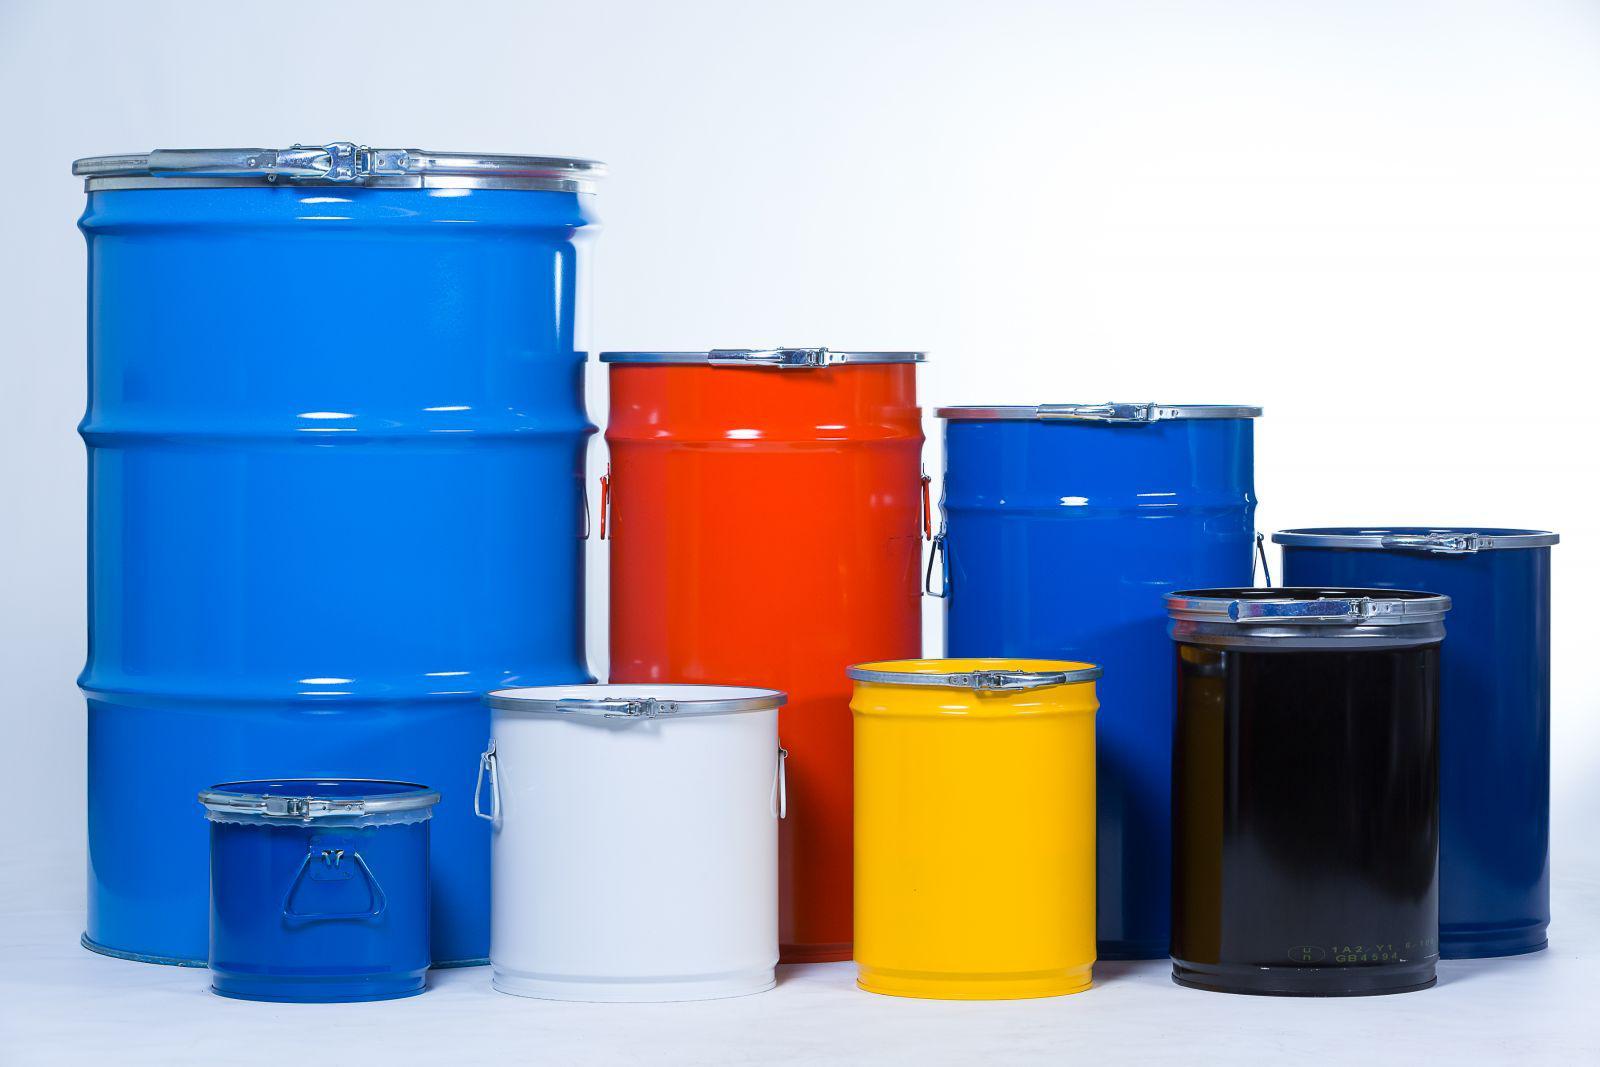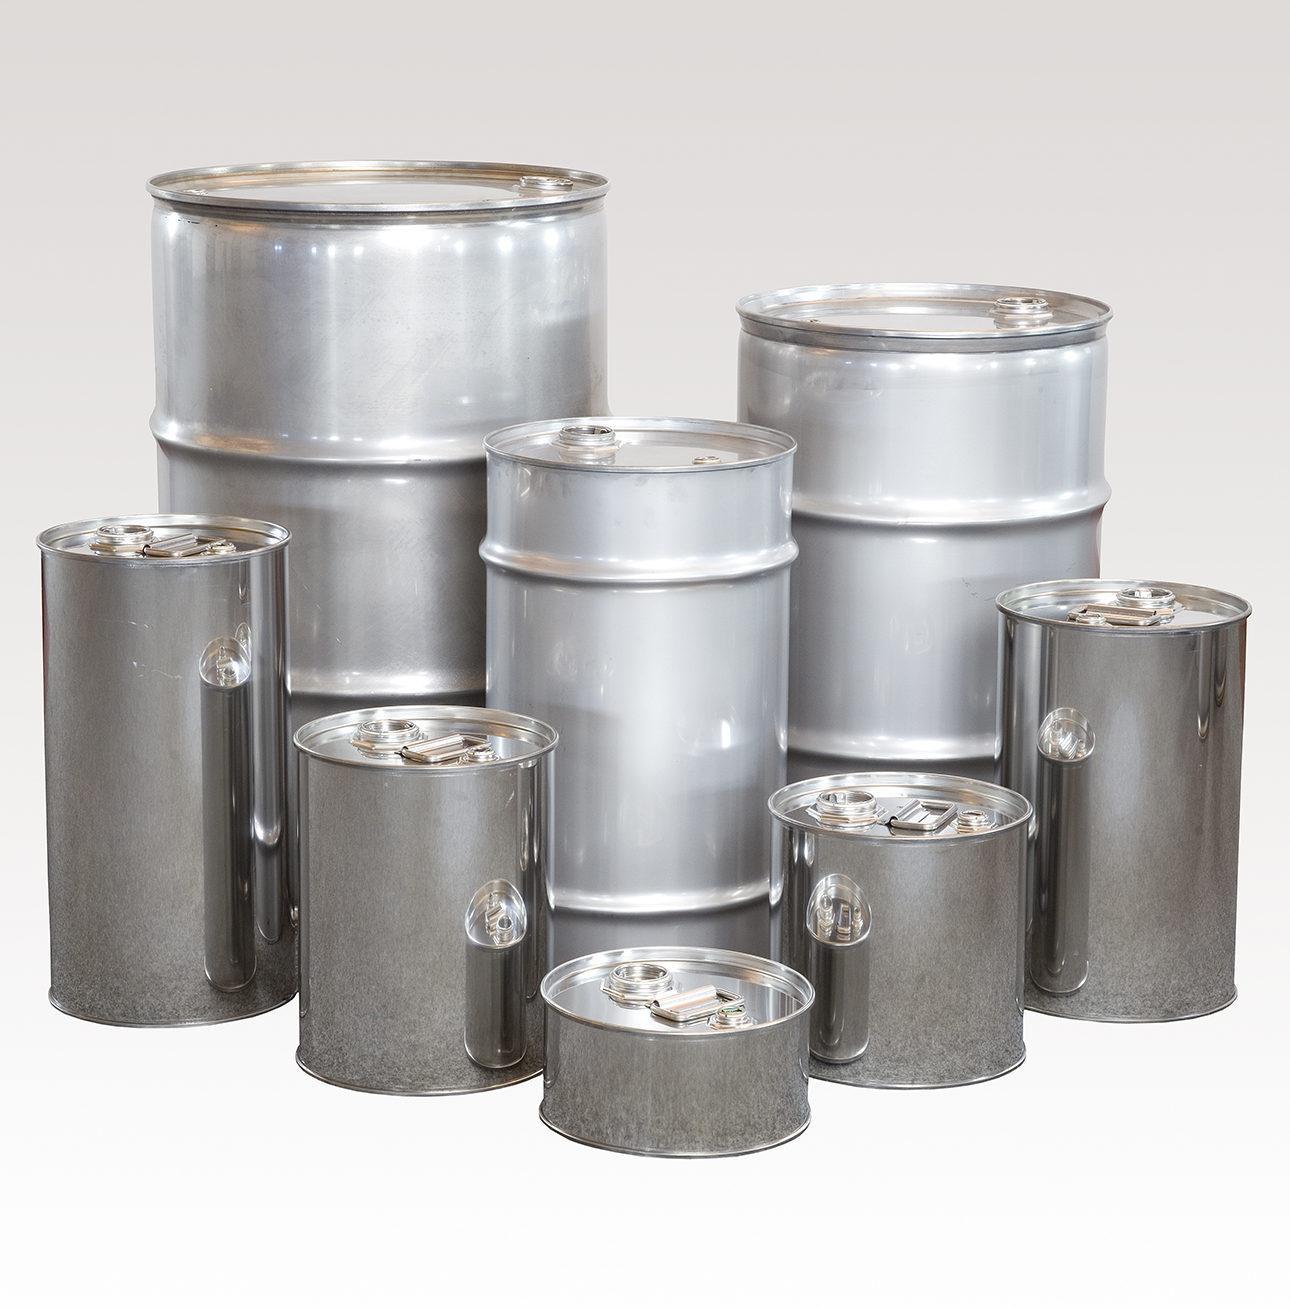The first image is the image on the left, the second image is the image on the right. For the images displayed, is the sentence "All barrels are gray steel and some barrels have open tops." factually correct? Answer yes or no. No. The first image is the image on the left, the second image is the image on the right. Evaluate the accuracy of this statement regarding the images: "There are more silver barrels in the image on the left than on the right.". Is it true? Answer yes or no. No. 